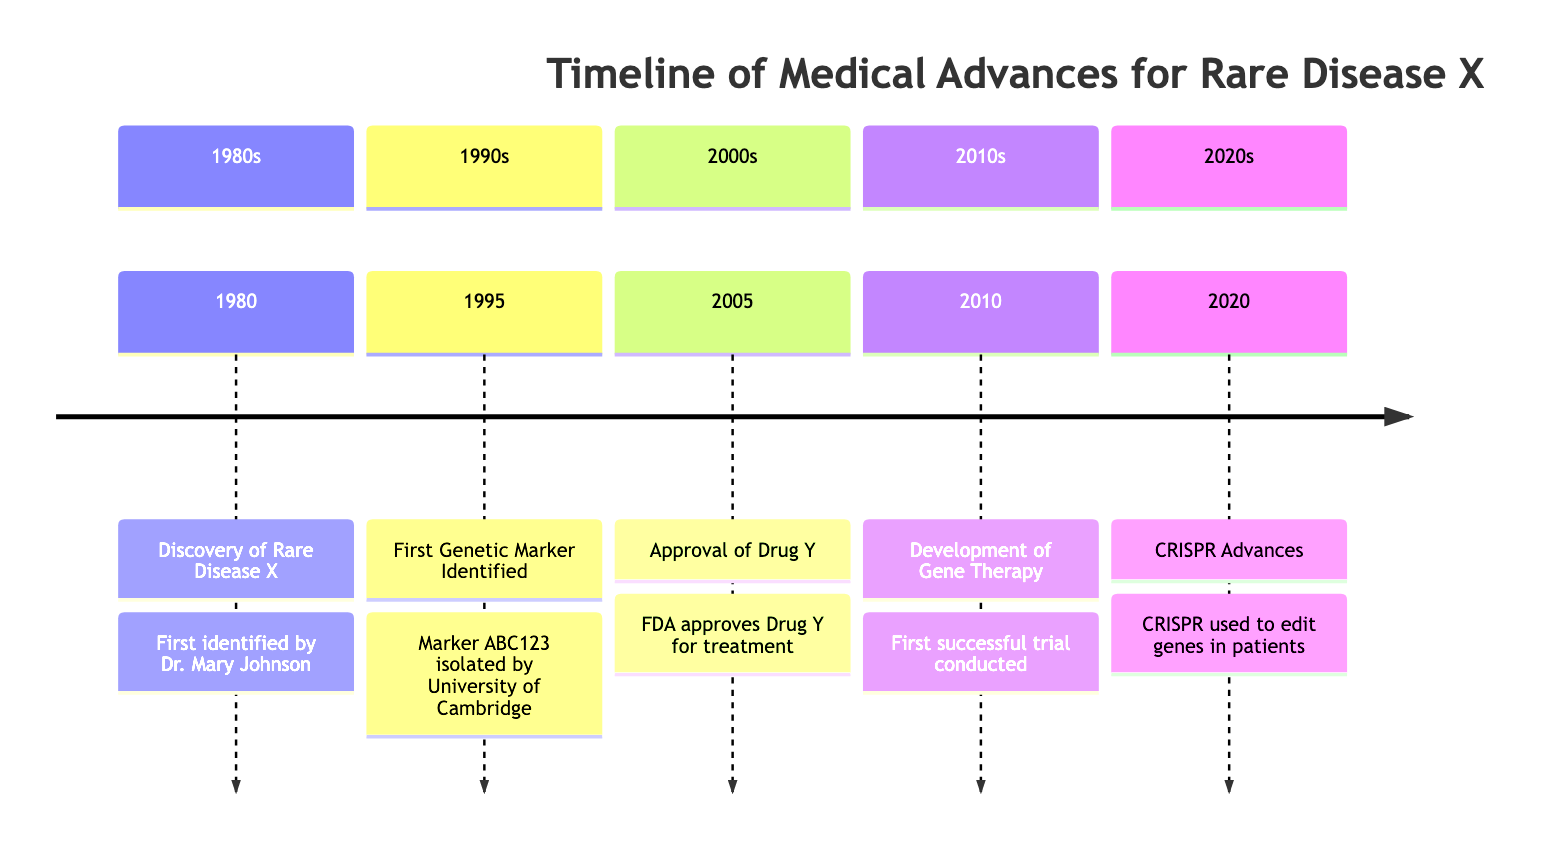What year was Rare Disease X first identified? The diagram indicates that Rare Disease X was first identified in the year 1980. Thus, the key milestone is directly linked to that year, which is explicitly mentioned in the timeline.
Answer: 1980 Who identified Rare Disease X? According to the diagram, Dr. Mary Johnson is credited with the identification of Rare Disease X in 1980. This is a direct statement found in the timeline section regarding that year’s milestone.
Answer: Dr. Mary Johnson What significant milestone occurred in 1995? The timeline shows that in 1995, the first genetic marker (ABC123) was identified. This is highlighted as a major milestone within that decade.
Answer: First Genetic Marker Identified How many milestones are listed in the 2000s? The diagram shows one milestone in the 2000s, which is the approval of Drug Y in 2005. Counting the events in that section confirms this observation.
Answer: 1 What advancement in genetic research occurred in 2020? The diagram notes that in 2020, CRISPR technology was used to edit genes in patients. This is a significant advancement depicted in the timeline.
Answer: CRISPR Advances Which decade saw the first successful trial of gene therapy? The timeline indicates that the first successful trial of gene therapy occurred in 2010, which places this milestone in the 2010s decade. To find this, we refer directly to the events listed in that section.
Answer: 2010s What two milestones took place in the 2010s? In the timeline, the two milestones listed for the 2010s are mainly the development of gene therapy in 2010 and the advancement of CRISPR in 2020. Thus, both events can be directly identified.
Answer: Development of Gene Therapy, CRISPR Advances How does the first genetic marker relate to the identification of the rare disease? The first genetic marker identified in 1995 (Marker ABC123) is closely related to the discovery of Rare Disease X, as it builds upon the initial identification made in 1980, providing essential genetic understanding necessary for further research and treatment developments. This relationship provides insight into the progression of medical understanding regarding the rare disease.
Answer: It builds upon the initial identification What is the last major milestone listed on the timeline? The last major milestone highlighted in the timeline is from 2020, where CRISPR was used for gene editing in patients. This conclusion is derived from examining the final entry in the timeline presented.
Answer: CRISPR Advances 